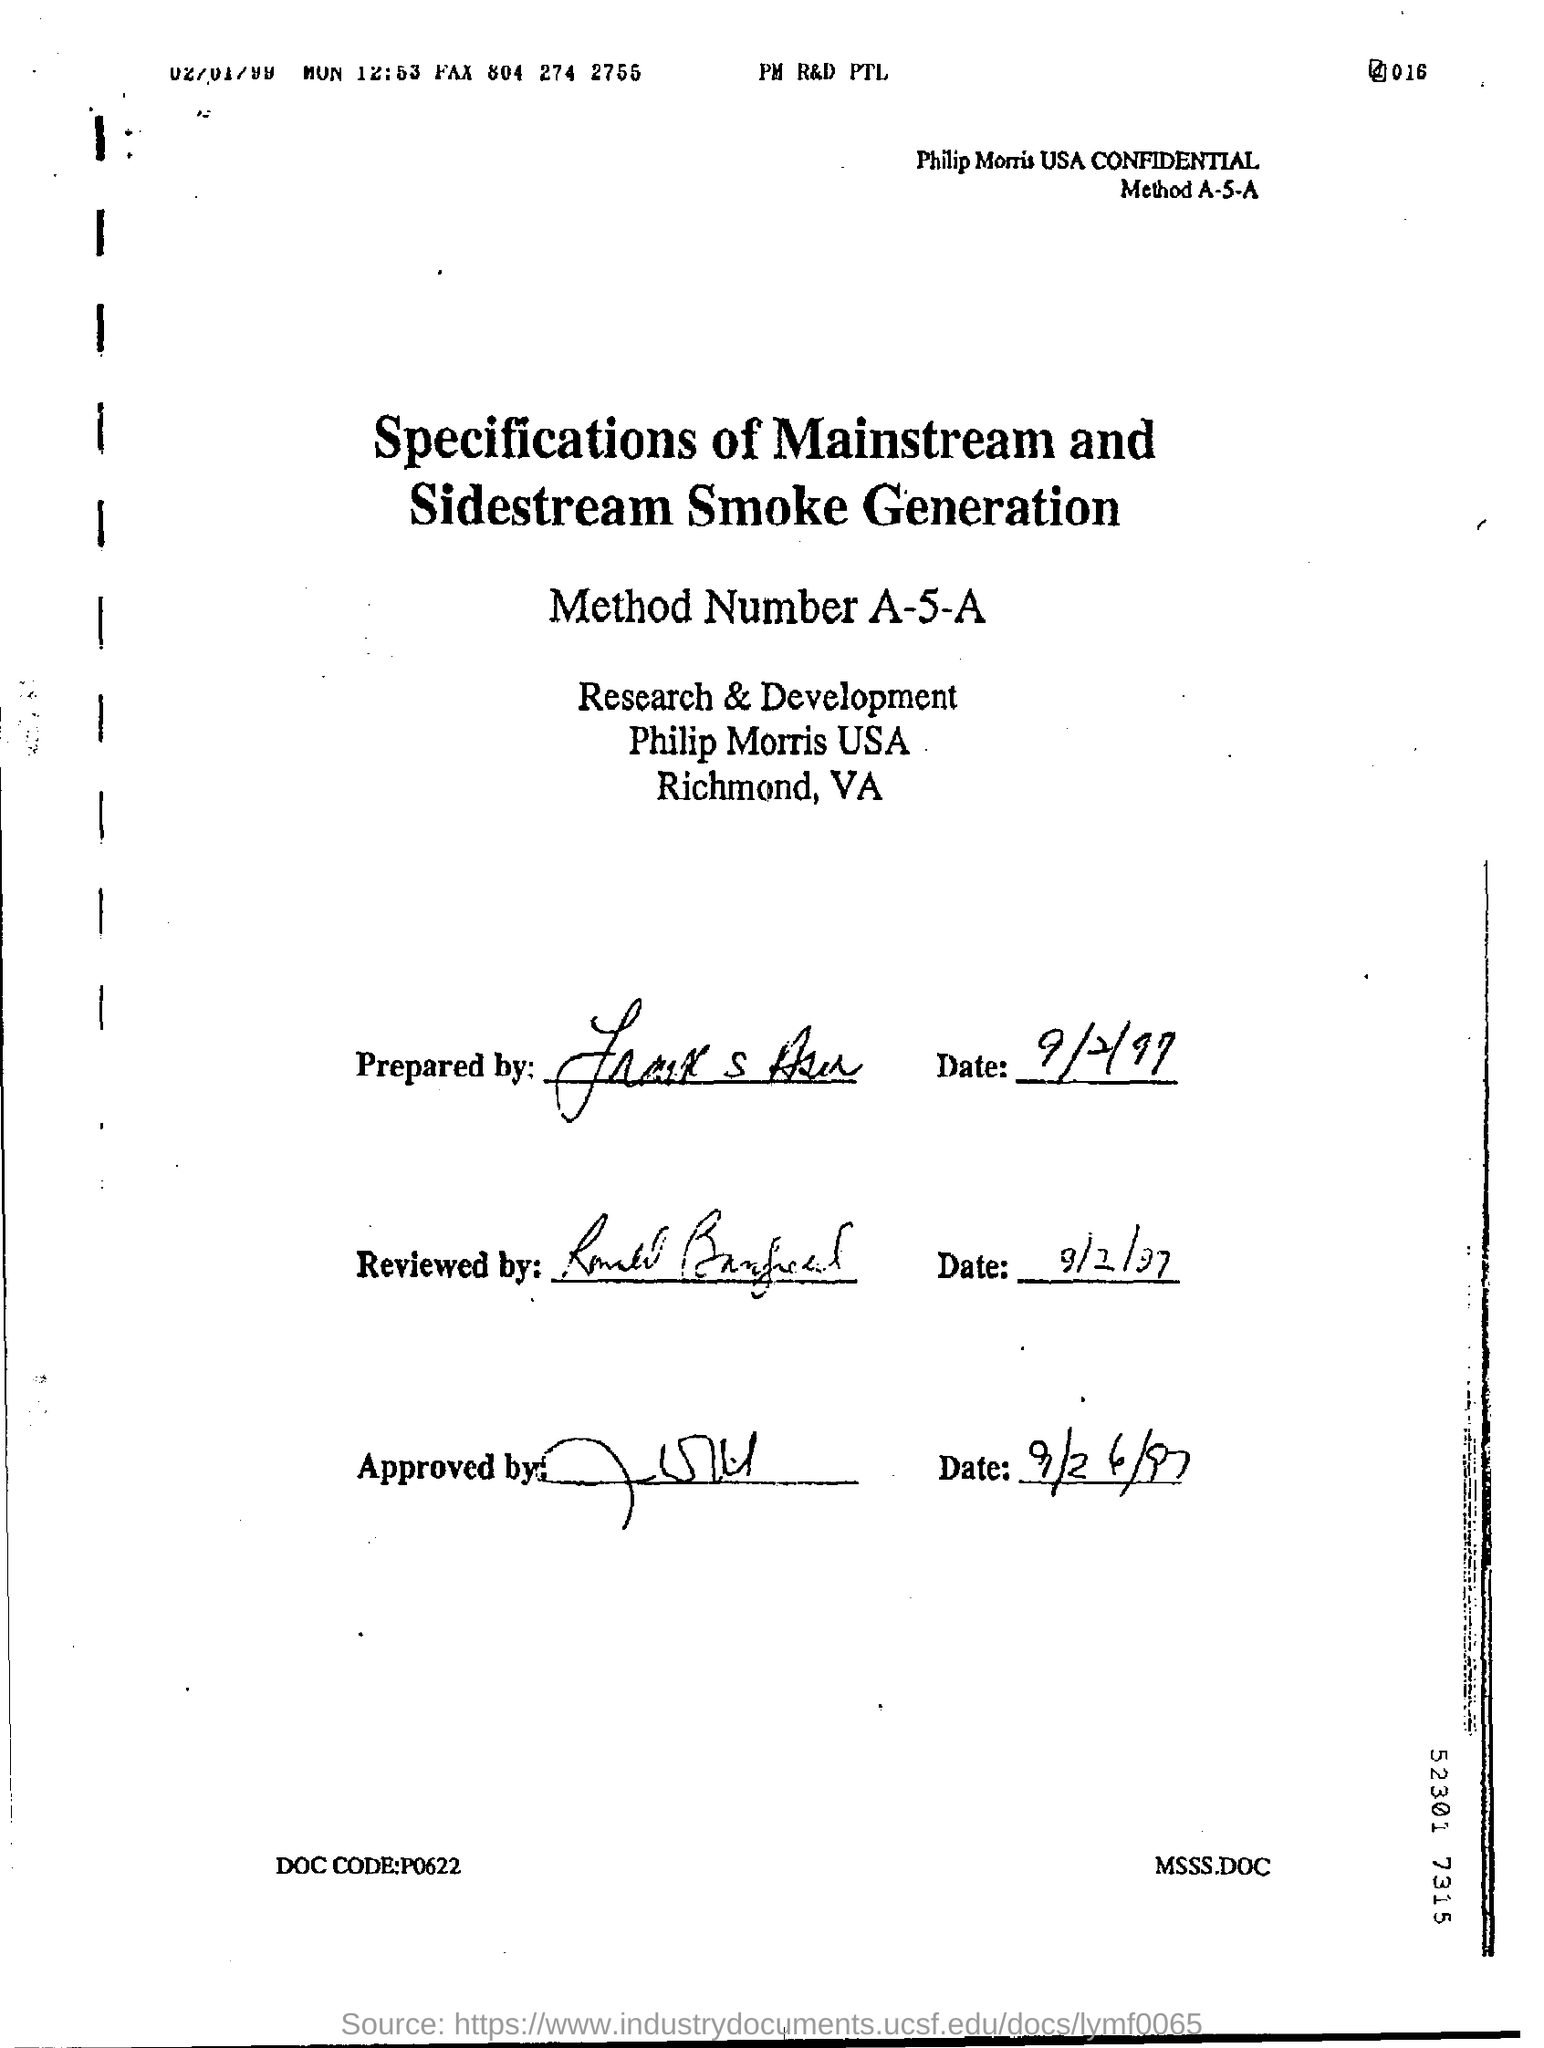What is the method number mentioned in the page ?
Ensure brevity in your answer.  A-5-A. On which date this letter was reviewed ?
Keep it short and to the point. 9/2/97. 